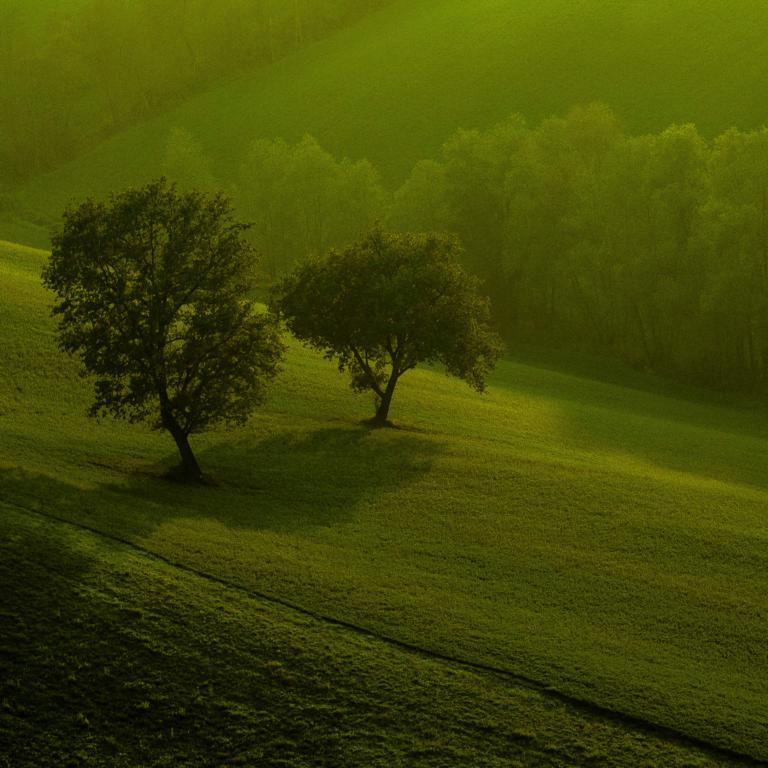What type of vegetation can be seen in the image? There is grass and trees in the image. Can you describe the natural setting in the image? The natural setting includes grass and trees. How many gloves can be seen hanging from the trees in the image? There are no gloves present in the image; it only features grass and trees. What type of fruit can be seen growing on the grass in the image? There are no fruits, including oranges, growing on the grass in the image. 